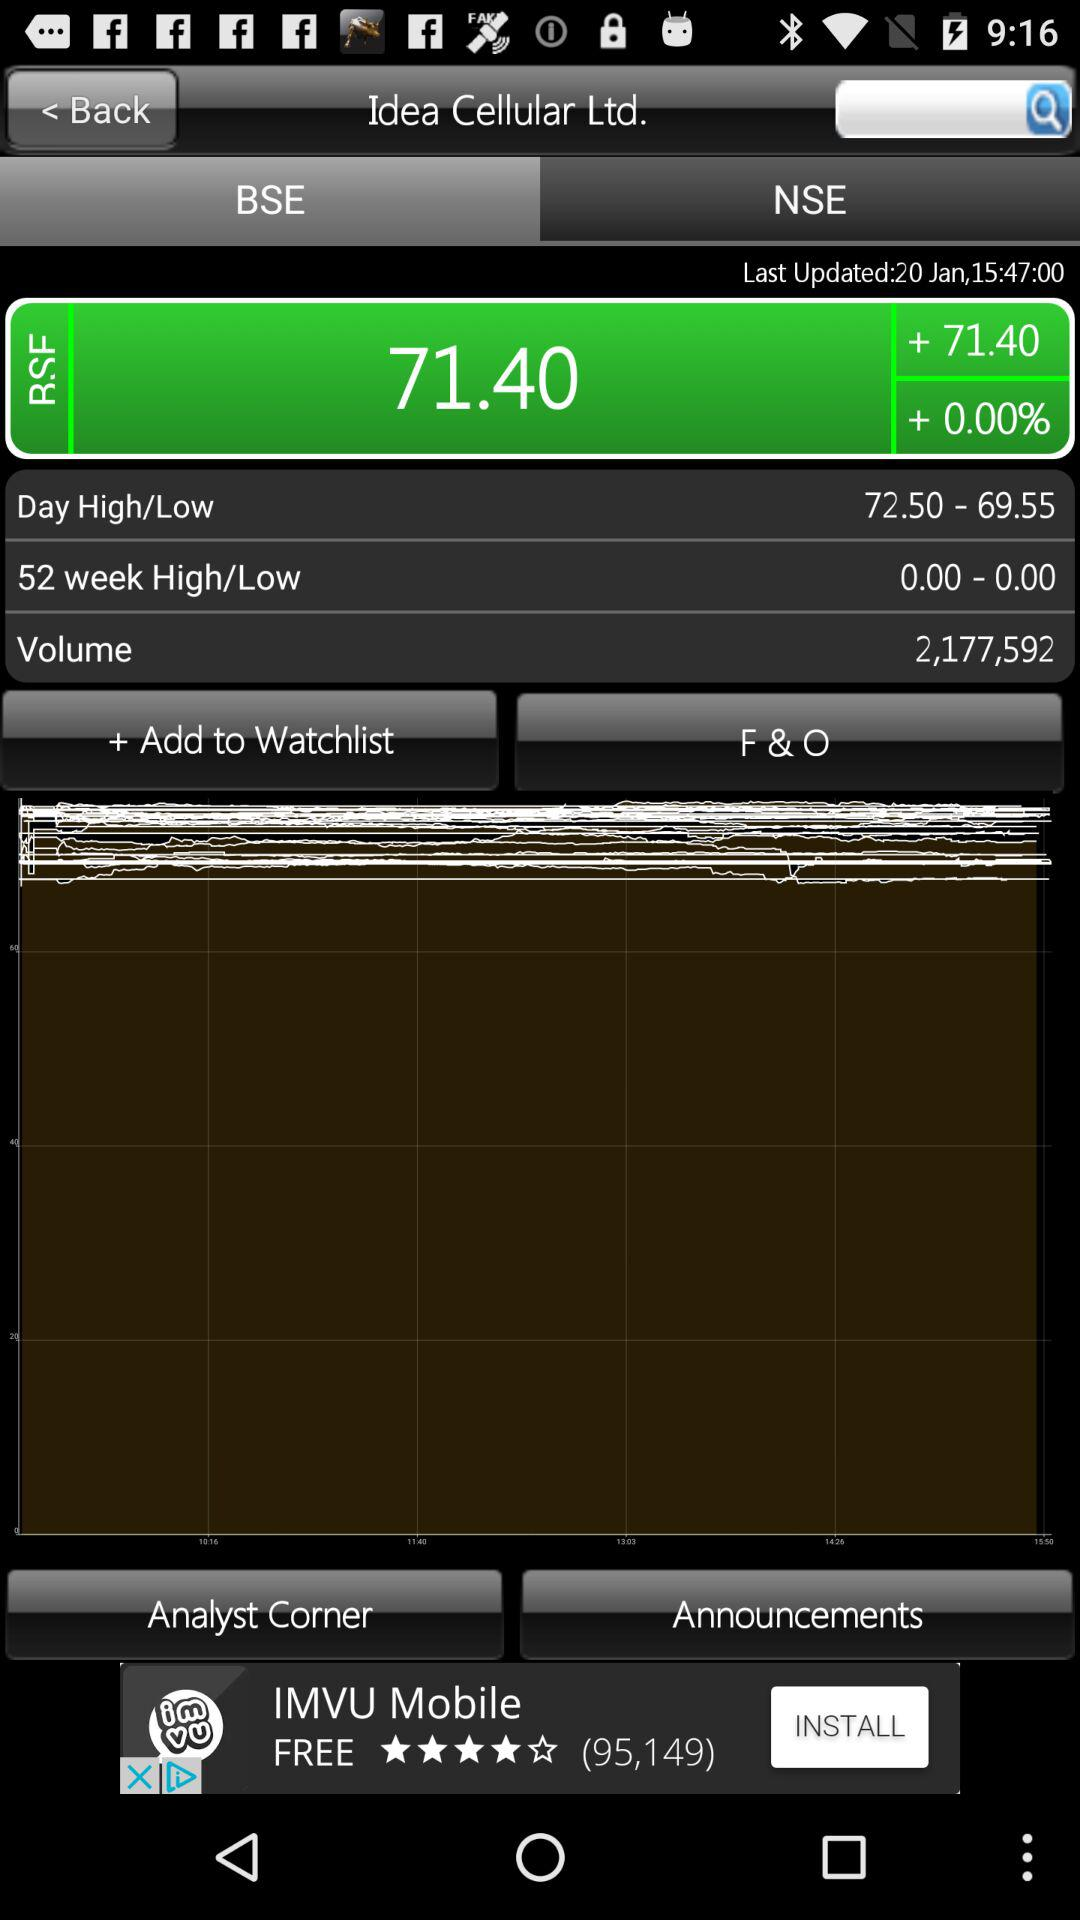What is the volume of the BSE? The volume of the BSE is 2,177,592. 